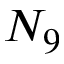Convert formula to latex. <formula><loc_0><loc_0><loc_500><loc_500>N _ { 9 }</formula> 